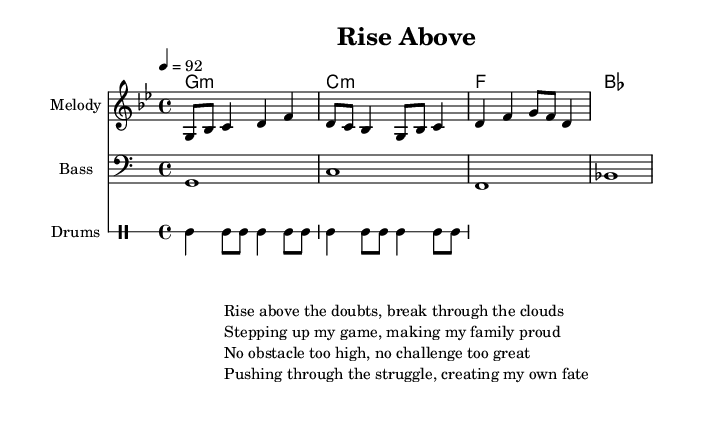What is the key signature of this music? The key signature is G minor. This can be determined from the key indicated at the beginning of the score, which shows a flat symbol corresponding to G minor (2 flats).
Answer: G minor What is the time signature of this music? The time signature is 4/4. This is visible in the score where it indicates that there are 4 beats in each measure, and the quarter note gets one beat.
Answer: 4/4 What is the tempo marking for this piece? The tempo marking is 92 BPM. This is noted above the staff in the score, indicating the speed at which the piece should be played.
Answer: 92 How many measures are there in the melody line? There are 4 measures in the melody line. By counting the divisions between the bar lines in the melody section, we see there are 4 separate segments, each representing a measure.
Answer: 4 What is the lyrical theme of the rap? The lyrical theme focuses on overcoming obstacles and achieving goals. The lyrics provide various affirmations about personal growth, perseverance, and pride in achievements, which encapsulates the essence of an inspirational anthem.
Answer: Overcoming obstacles What type of instruments are included in this piece? The piece includes a melody, bass, and drums. Each is noted by their respective staff labels, and the specific parts for each instrument are provided in the score.
Answer: Melody, Bass, Drums What kind of rhythmic pattern is utilized in the drum section? The drum section employs a basic hip-hop beat. This is recognizable from the combination of bass drum and snare patterns familiar in hip-hop music, providing a steady and consistent rhythm.
Answer: Hip-hop beat 